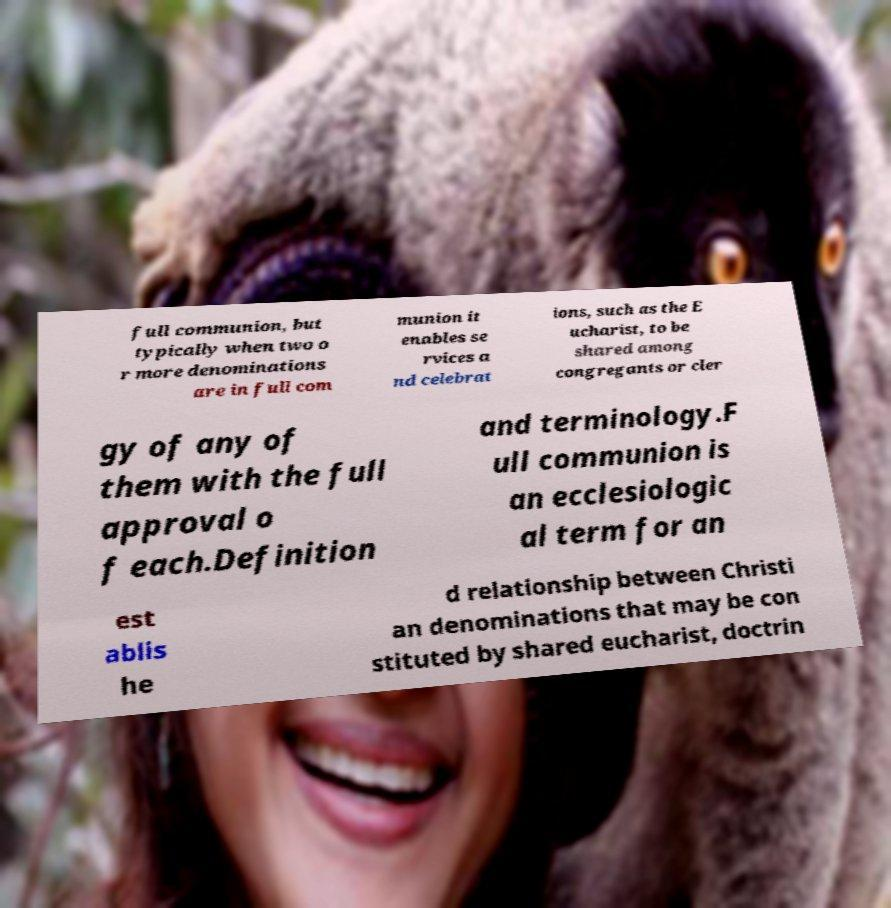What messages or text are displayed in this image? I need them in a readable, typed format. full communion, but typically when two o r more denominations are in full com munion it enables se rvices a nd celebrat ions, such as the E ucharist, to be shared among congregants or cler gy of any of them with the full approval o f each.Definition and terminology.F ull communion is an ecclesiologic al term for an est ablis he d relationship between Christi an denominations that may be con stituted by shared eucharist, doctrin 